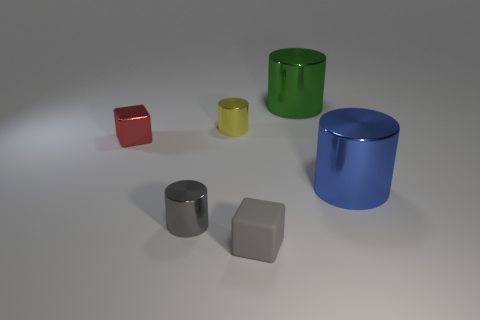Subtract all small yellow shiny cylinders. How many cylinders are left? 3 Add 3 tiny gray objects. How many objects exist? 9 Subtract all blue cylinders. How many cylinders are left? 3 Subtract all big brown rubber cubes. Subtract all large metallic cylinders. How many objects are left? 4 Add 6 red things. How many red things are left? 7 Add 3 tiny green cylinders. How many tiny green cylinders exist? 3 Subtract 0 red cylinders. How many objects are left? 6 Subtract all cylinders. How many objects are left? 2 Subtract all yellow cylinders. Subtract all cyan blocks. How many cylinders are left? 3 